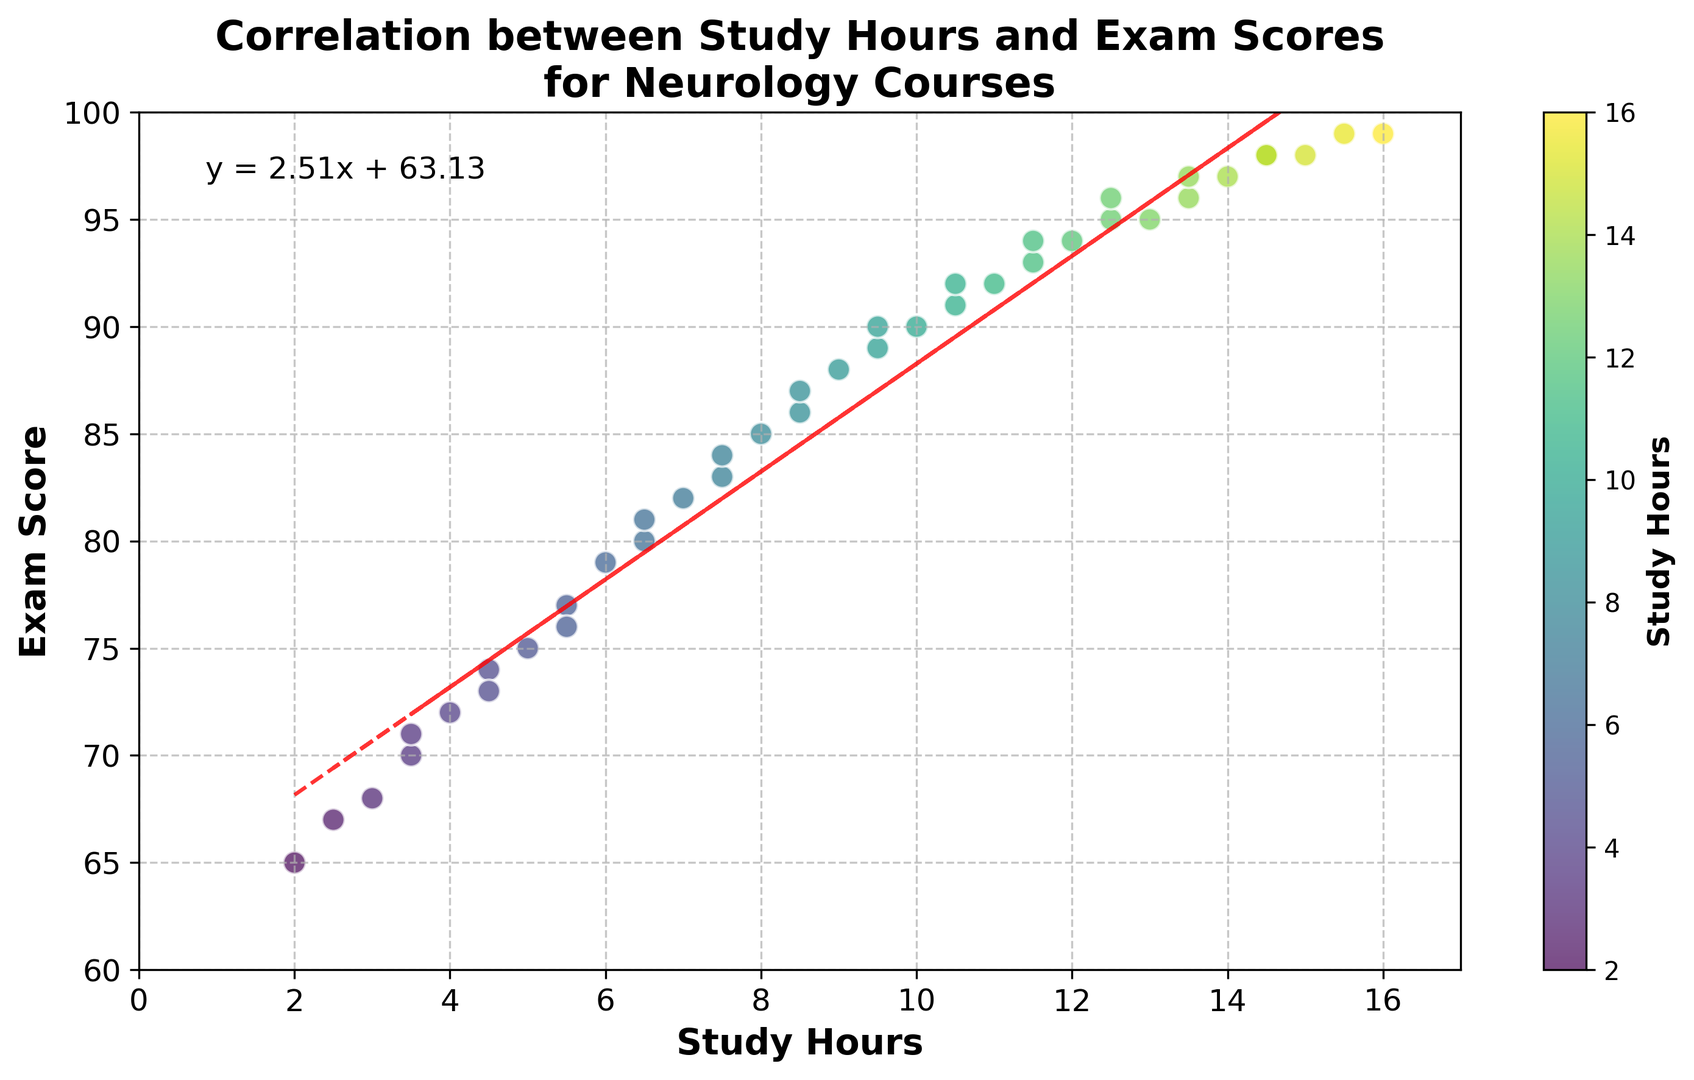What is the highest exam score shown? The highest exam score can be observed from the topmost point in the scatter plot. By looking at the y-axis and the points plotted, we can see that the highest exam score is 99.
Answer: 99 What is the equation of the regression line? The equation of the regression line is usually indicated on the chart itself. In this figure, it is given as \( y = 2.21x + 62.69 \), which is displayed as text somewhere on the plot.
Answer: y = 2.21x + 62.69 Which exam score is achieved with the least amount of study hours? By looking at the scatter plot, find the point that is closest to the y-axis (representing the least study hours) and check its corresponding y-value. The point for 2 study hours corresponds to an exam score of 65.
Answer: 65 How many hours of study are needed to achieve an exam score of 90? To find this, observe the point on the y-axis where exam score is 90 and trace horizontally to the scatter points. The study hours corresponding to this score are around 10 hours.
Answer: 10 What is the range of study hours shown in the figure? The range of study hours is determined by the minimum and maximum values on the x-axis. The minimum study hours is 2, and the maximum study hours is 16. Therefore, the range is 16 - 2 = 14 hours.
Answer: 14 What color represents the highest number of study hours? The colors in the scatter plot change according to the study hours, with a specific gradient. The highest study hours (16 hours) are represented by the deepest color on the color scale, which is dark green.
Answer: Dark green Compare the exam scores for students studying 5 hours and 10 hours. Observe the points corresponding to 5 hours and 10 hours on the x-axis and compare their y-values (exam scores). The exam score for 5 hours is 75, and for 10 hours, it is 90. Therefore, the exam score increases by 15 points.
Answer: 15 points On average, how many points does each additional hour of study contribute to the exam score? The slope of the regression line gives the average increase in exam score per additional hour of study. From the regression line equation, the slope is 2.21, which means each additional hour of study contributes an average of 2.21 points to the exam score.
Answer: 2.21 points Which point shows the largest deviation from the regression line? To determine this, look for the point that is farthest away from the red dashed regression line. Visually, this can be assessed by observing the vertical distance between each scatter point and the line. This point would also be mentioned in the context of visual inspection in a detailed analysis.
Answer: The point around 2 study hours (65 exam score) 